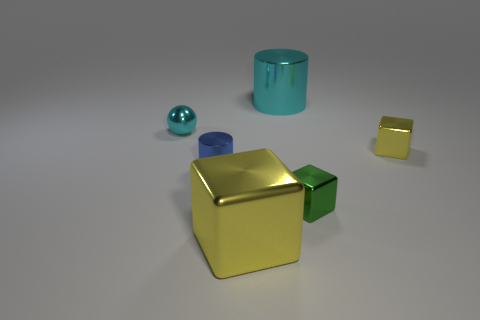Subtract all tiny blocks. How many blocks are left? 1 Subtract all green balls. How many yellow cubes are left? 2 Add 1 large cyan things. How many objects exist? 7 Subtract all cylinders. How many objects are left? 4 Add 5 large metal cylinders. How many large metal cylinders exist? 6 Subtract 0 green cylinders. How many objects are left? 6 Subtract all tiny metal blocks. Subtract all yellow metallic blocks. How many objects are left? 2 Add 6 big metallic cubes. How many big metallic cubes are left? 7 